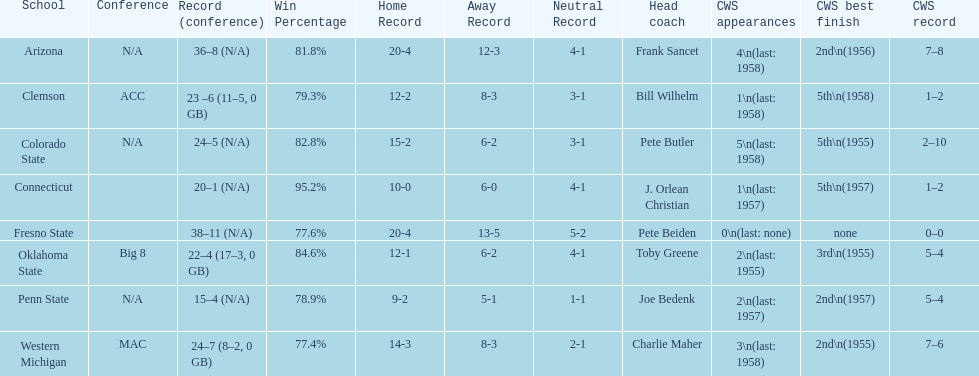List each of the schools that came in 2nd for cws best finish. Arizona, Penn State, Western Michigan. 